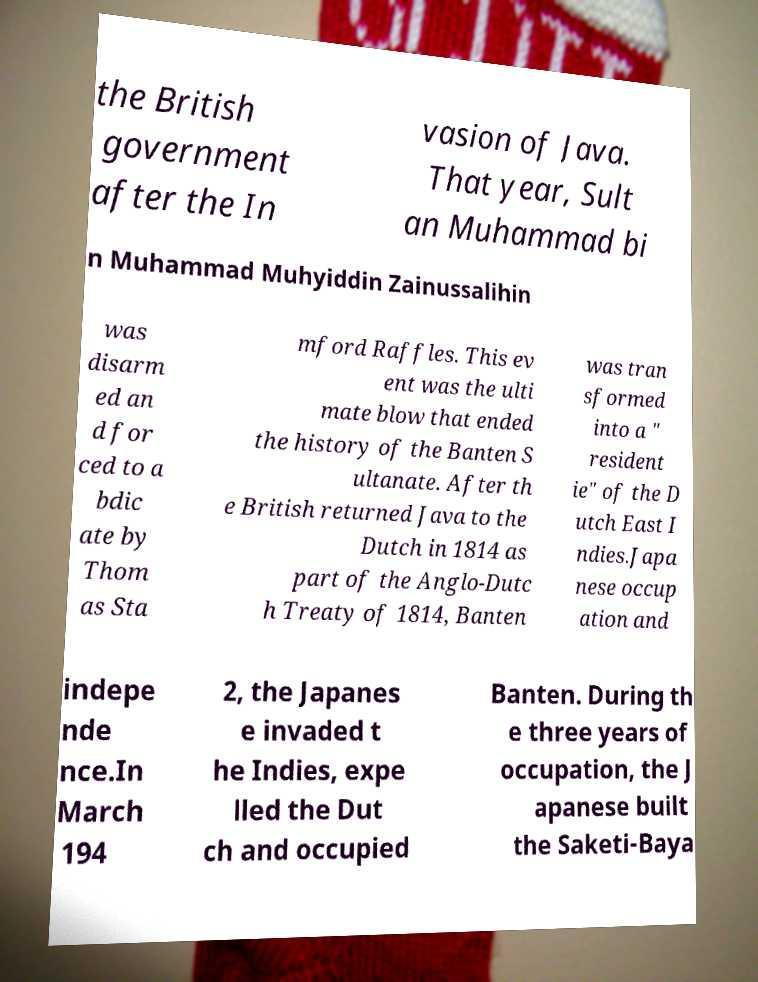There's text embedded in this image that I need extracted. Can you transcribe it verbatim? the British government after the In vasion of Java. That year, Sult an Muhammad bi n Muhammad Muhyiddin Zainussalihin was disarm ed an d for ced to a bdic ate by Thom as Sta mford Raffles. This ev ent was the ulti mate blow that ended the history of the Banten S ultanate. After th e British returned Java to the Dutch in 1814 as part of the Anglo-Dutc h Treaty of 1814, Banten was tran sformed into a " resident ie" of the D utch East I ndies.Japa nese occup ation and indepe nde nce.In March 194 2, the Japanes e invaded t he Indies, expe lled the Dut ch and occupied Banten. During th e three years of occupation, the J apanese built the Saketi-Baya 